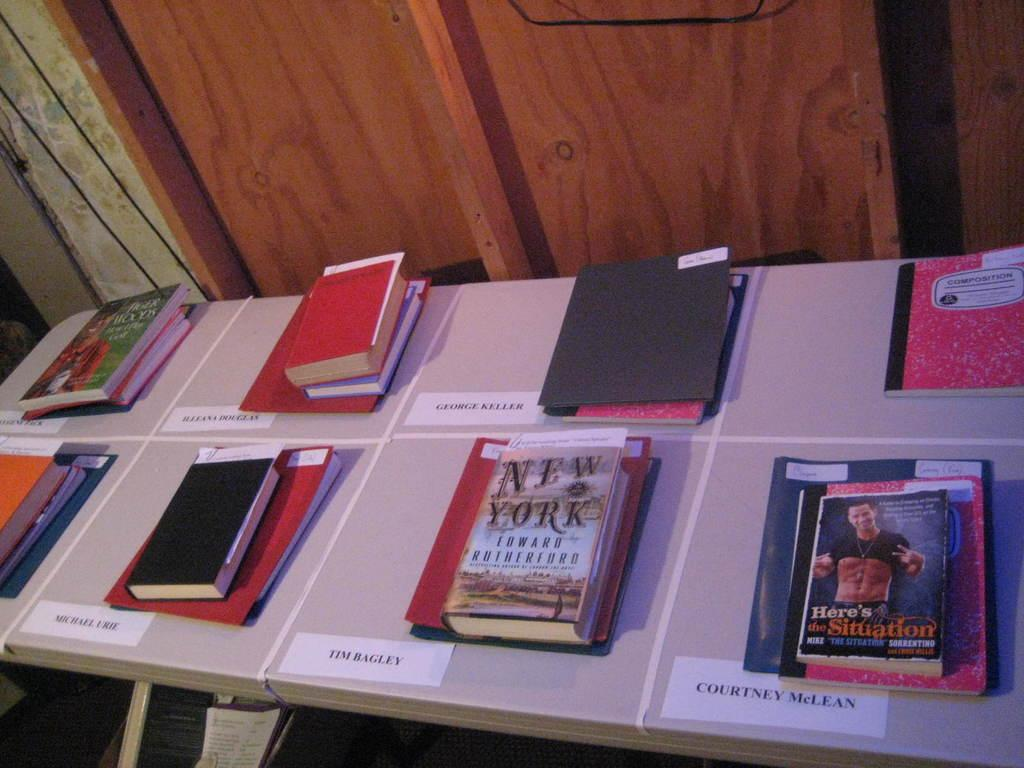<image>
Provide a brief description of the given image. Small piles of books are arranged on a table with people's names by them, one of the books is about New York. 